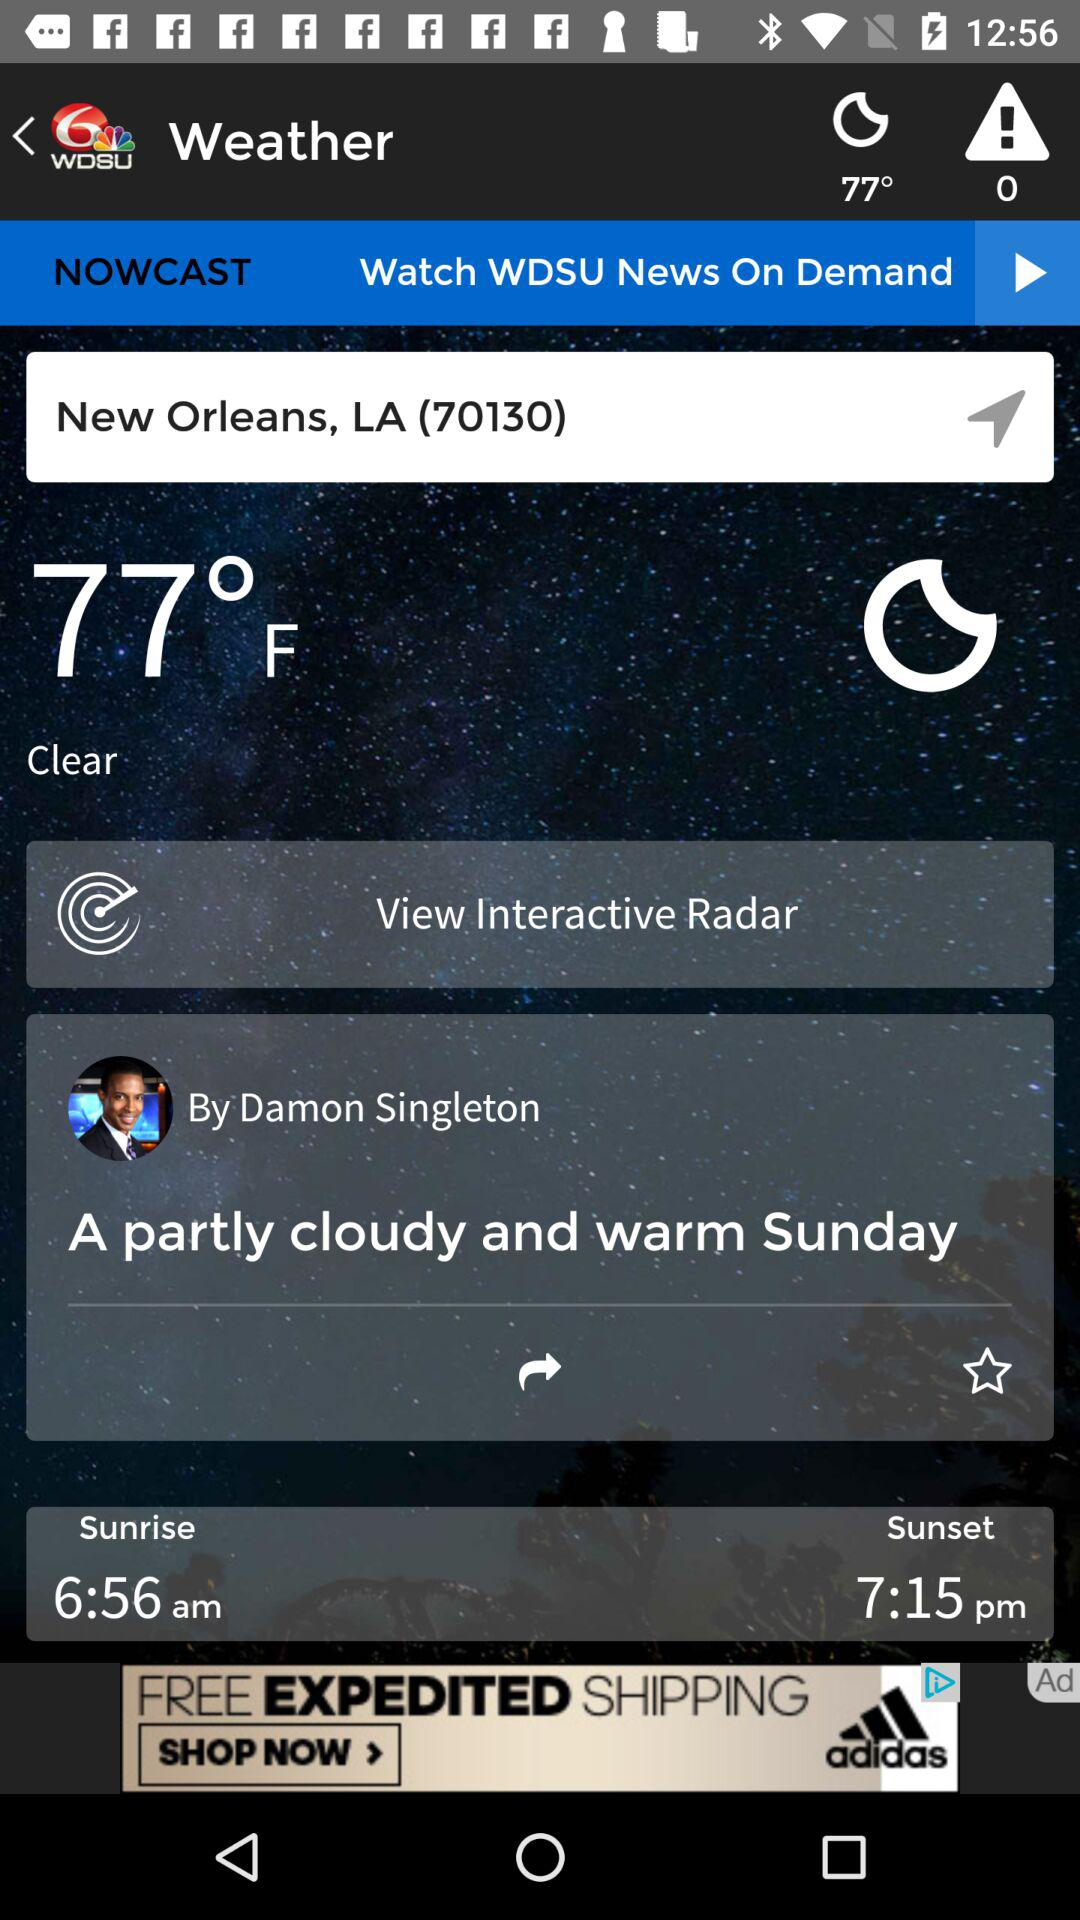What is the unit of the temperature? The unit of the temperature is °F. 